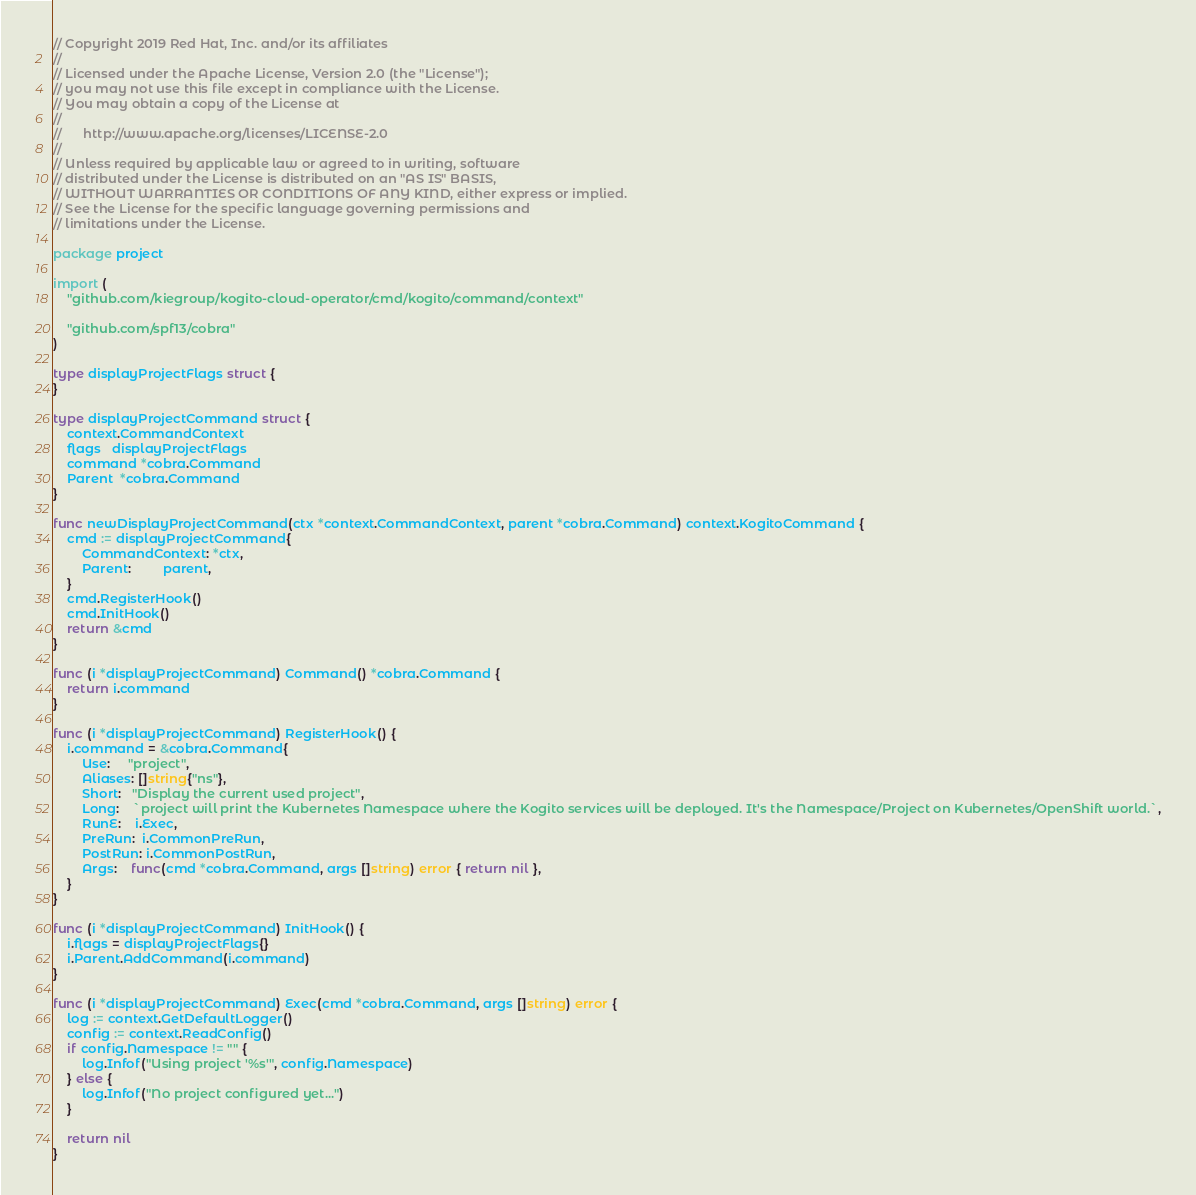Convert code to text. <code><loc_0><loc_0><loc_500><loc_500><_Go_>// Copyright 2019 Red Hat, Inc. and/or its affiliates
//
// Licensed under the Apache License, Version 2.0 (the "License");
// you may not use this file except in compliance with the License.
// You may obtain a copy of the License at
//
//      http://www.apache.org/licenses/LICENSE-2.0
//
// Unless required by applicable law or agreed to in writing, software
// distributed under the License is distributed on an "AS IS" BASIS,
// WITHOUT WARRANTIES OR CONDITIONS OF ANY KIND, either express or implied.
// See the License for the specific language governing permissions and
// limitations under the License.

package project

import (
	"github.com/kiegroup/kogito-cloud-operator/cmd/kogito/command/context"

	"github.com/spf13/cobra"
)

type displayProjectFlags struct {
}

type displayProjectCommand struct {
	context.CommandContext
	flags   displayProjectFlags
	command *cobra.Command
	Parent  *cobra.Command
}

func newDisplayProjectCommand(ctx *context.CommandContext, parent *cobra.Command) context.KogitoCommand {
	cmd := displayProjectCommand{
		CommandContext: *ctx,
		Parent:         parent,
	}
	cmd.RegisterHook()
	cmd.InitHook()
	return &cmd
}

func (i *displayProjectCommand) Command() *cobra.Command {
	return i.command
}

func (i *displayProjectCommand) RegisterHook() {
	i.command = &cobra.Command{
		Use:     "project",
		Aliases: []string{"ns"},
		Short:   "Display the current used project",
		Long:    `project will print the Kubernetes Namespace where the Kogito services will be deployed. It's the Namespace/Project on Kubernetes/OpenShift world.`,
		RunE:    i.Exec,
		PreRun:  i.CommonPreRun,
		PostRun: i.CommonPostRun,
		Args:    func(cmd *cobra.Command, args []string) error { return nil },
	}
}

func (i *displayProjectCommand) InitHook() {
	i.flags = displayProjectFlags{}
	i.Parent.AddCommand(i.command)
}

func (i *displayProjectCommand) Exec(cmd *cobra.Command, args []string) error {
	log := context.GetDefaultLogger()
	config := context.ReadConfig()
	if config.Namespace != "" {
		log.Infof("Using project '%s'", config.Namespace)
	} else {
		log.Infof("No project configured yet...")
	}

	return nil
}
</code> 